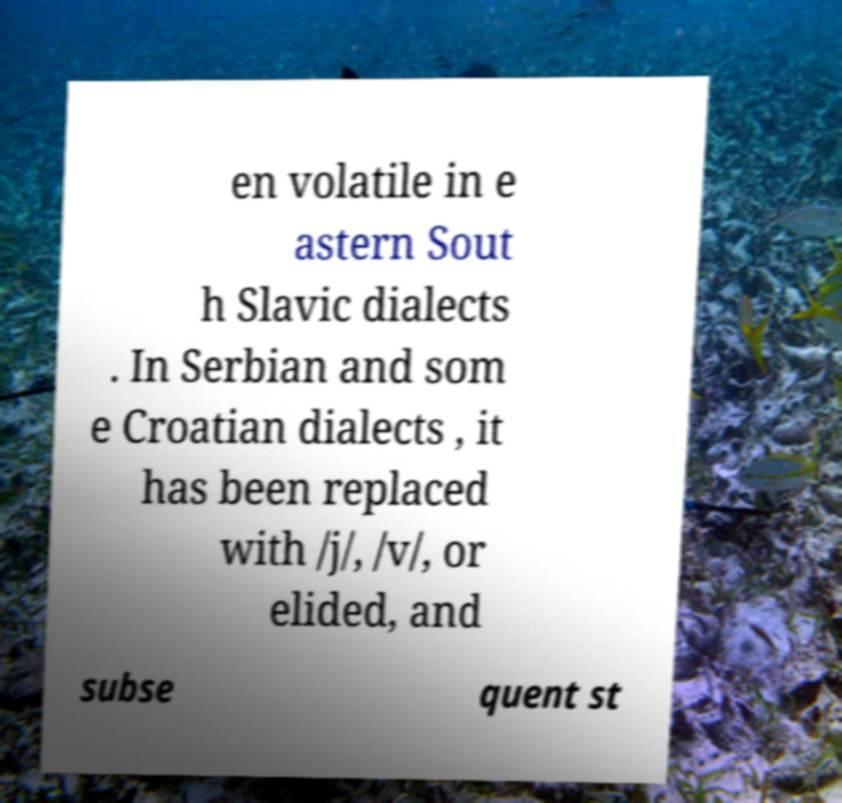Could you assist in decoding the text presented in this image and type it out clearly? en volatile in e astern Sout h Slavic dialects . In Serbian and som e Croatian dialects , it has been replaced with /j/, /v/, or elided, and subse quent st 